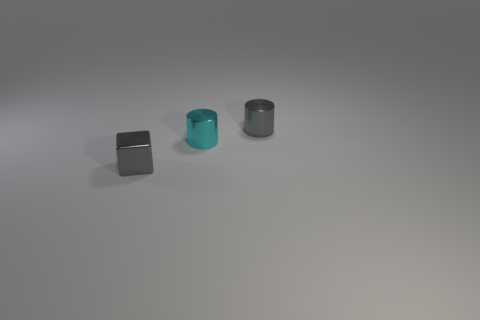Are there more shiny cylinders left of the gray metal cylinder than gray cylinders to the left of the cyan object?
Make the answer very short. Yes. What number of spheres are tiny cyan metal things or tiny shiny things?
Keep it short and to the point. 0. Are there any other things that have the same size as the cyan metal thing?
Offer a very short reply. Yes. There is a shiny object that is behind the small cyan metallic object; is it the same shape as the tiny cyan thing?
Provide a short and direct response. Yes. How many other tiny metallic things have the same shape as the tiny cyan shiny thing?
Your answer should be compact. 1. What number of things are small cyan shiny cylinders or cyan metallic objects that are on the right side of the tiny cube?
Give a very brief answer. 1. There is a tiny cube; does it have the same color as the metal cylinder that is behind the cyan thing?
Ensure brevity in your answer.  Yes. Are there any shiny things behind the small cyan thing?
Offer a very short reply. Yes. Are there any small metal things in front of the tiny cylinder left of the small gray cylinder?
Keep it short and to the point. Yes. Is the number of gray metallic blocks left of the tiny gray cylinder the same as the number of small shiny objects that are behind the small gray metal cube?
Your response must be concise. No. 